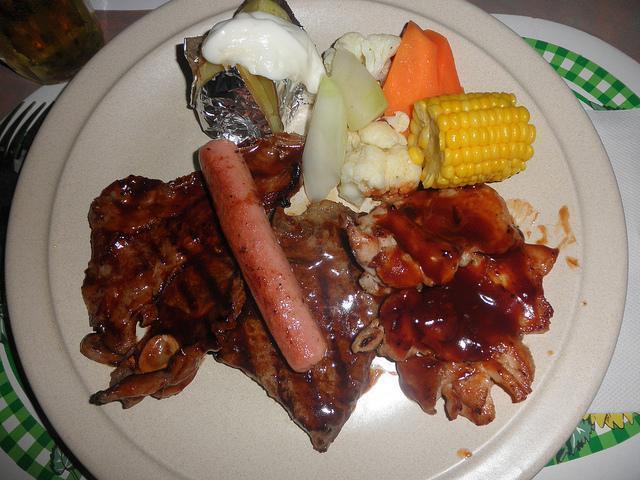Which dairy product is most prominent here?
Select the accurate response from the four choices given to answer the question.
Options: Cottage cheese, sour cream, cheese, milk. Sour cream. 